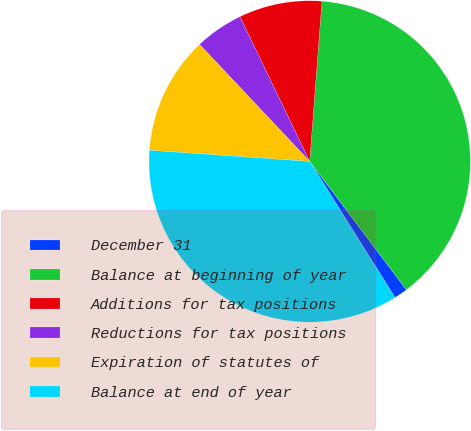Convert chart. <chart><loc_0><loc_0><loc_500><loc_500><pie_chart><fcel>December 31<fcel>Balance at beginning of year<fcel>Additions for tax positions<fcel>Reductions for tax positions<fcel>Expiration of statutes of<fcel>Balance at end of year<nl><fcel>1.37%<fcel>38.51%<fcel>8.37%<fcel>4.87%<fcel>11.87%<fcel>35.01%<nl></chart> 